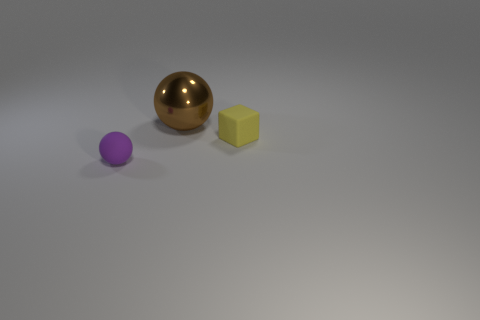If these objects were part of a game, what rules could apply to them based on their appearance? If these objects were game pieces, the rules might involve using the gold sphere as the primary object to be moved across the board due to its distinguished appearance. The cube could function as a die or a blocker, while the small purple object might be a special piece used for bonus points or extra moves, given its unique color and smaller size. 